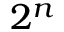<formula> <loc_0><loc_0><loc_500><loc_500>2 ^ { n }</formula> 